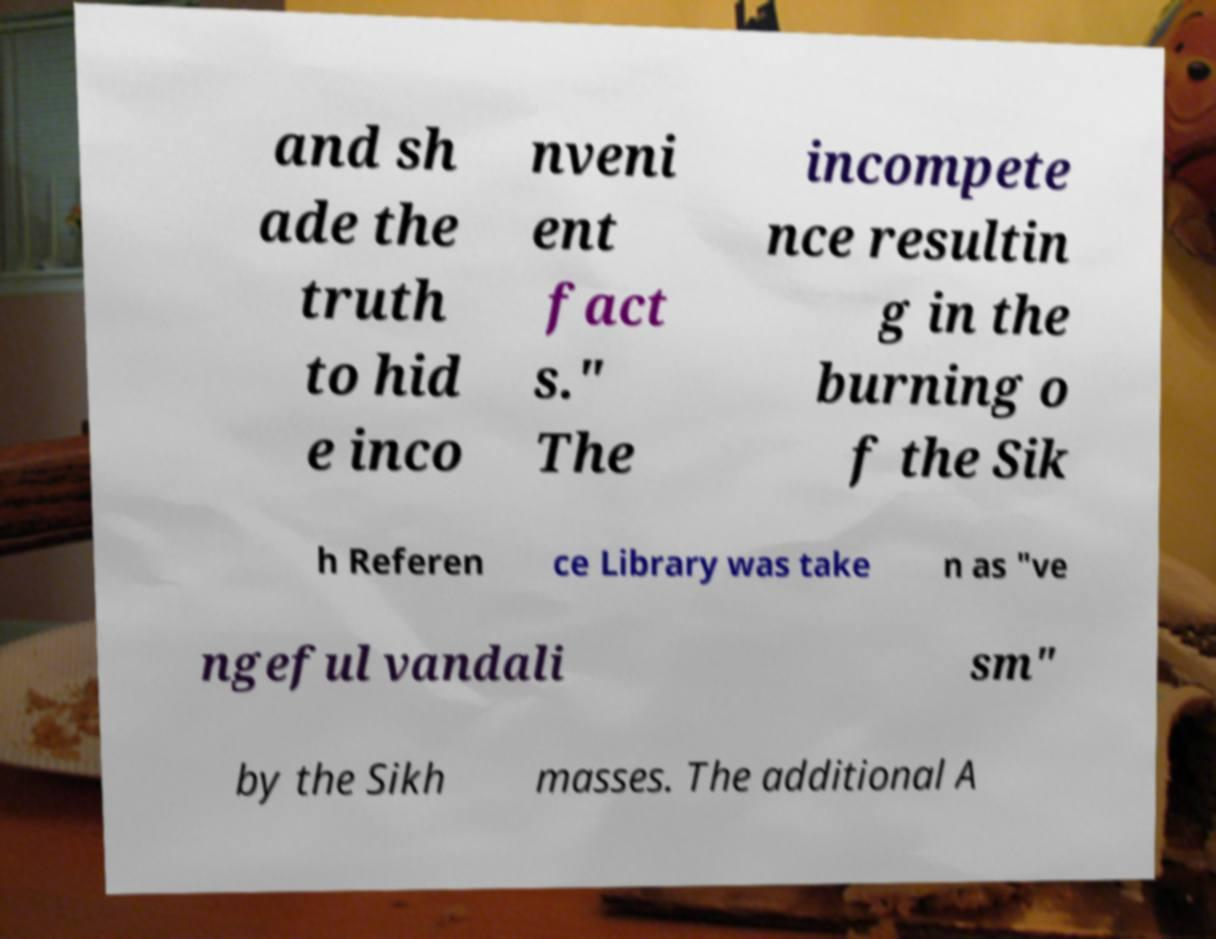I need the written content from this picture converted into text. Can you do that? and sh ade the truth to hid e inco nveni ent fact s." The incompete nce resultin g in the burning o f the Sik h Referen ce Library was take n as "ve ngeful vandali sm" by the Sikh masses. The additional A 